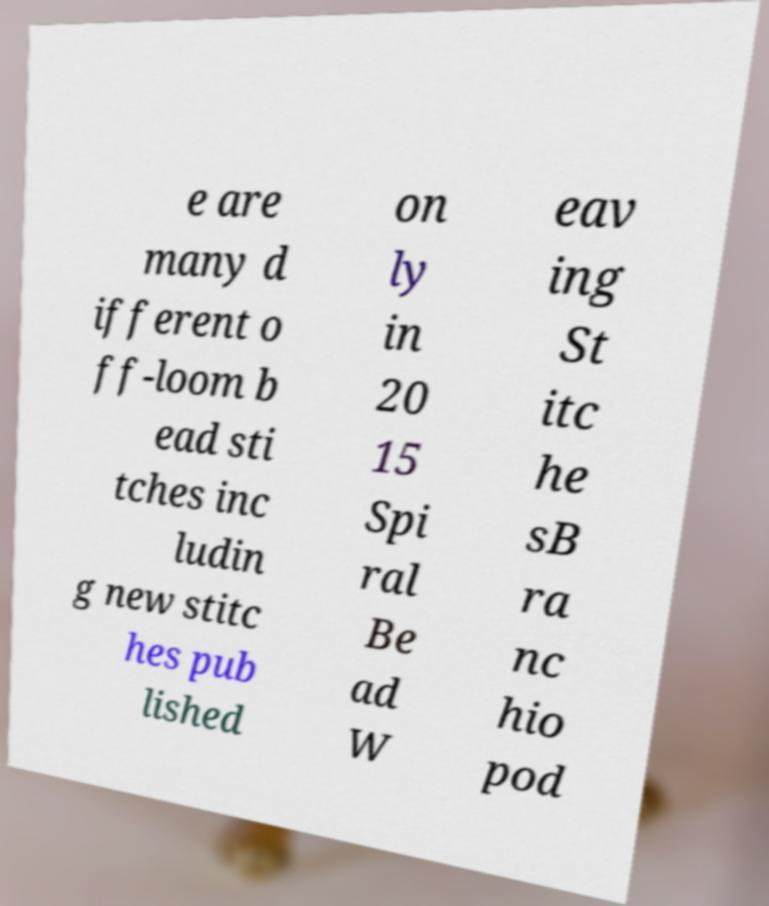Can you accurately transcribe the text from the provided image for me? e are many d ifferent o ff-loom b ead sti tches inc ludin g new stitc hes pub lished on ly in 20 15 Spi ral Be ad W eav ing St itc he sB ra nc hio pod 